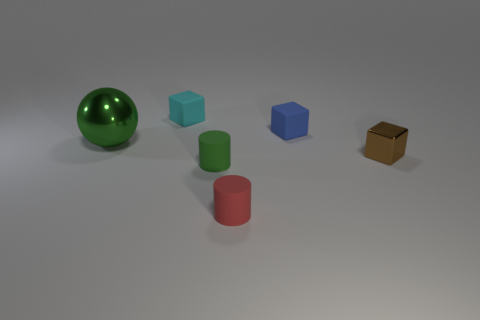Are there any other things that are the same size as the green ball?
Provide a succinct answer. No. Are there more tiny things behind the small blue matte block than large matte objects?
Offer a terse response. Yes. Are any cyan objects visible?
Make the answer very short. Yes. How many green balls have the same size as the brown metallic thing?
Ensure brevity in your answer.  0. Are there more tiny brown blocks in front of the blue cube than green rubber things that are left of the green metal thing?
Ensure brevity in your answer.  Yes. There is a red thing that is the same size as the brown block; what is it made of?
Give a very brief answer. Rubber. What shape is the big green thing?
Provide a succinct answer. Sphere. What number of yellow objects are either rubber things or big rubber spheres?
Keep it short and to the point. 0. The green object that is the same material as the small blue block is what size?
Offer a terse response. Small. Does the green thing behind the brown thing have the same material as the block in front of the metallic ball?
Keep it short and to the point. Yes. 